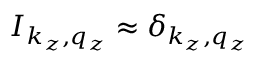Convert formula to latex. <formula><loc_0><loc_0><loc_500><loc_500>I _ { k _ { z } , q _ { z } } \approx \delta _ { k _ { z } , q _ { z } }</formula> 